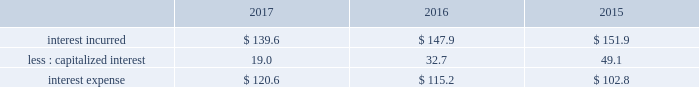Gain on previously held equity interest on 30 december 2014 , we acquired our partner 2019s equity ownership interest in a liquefied atmospheric industrial gases production joint venture in north america for $ 22.6 , which increased our ownership from 50% ( 50 % ) to 100% ( 100 % ) .
The transaction was accounted for as a business combination , and subsequent to the acquisition , the results were consolidated within our industrial gases 2013 americas segment .
We recorded a gain of $ 17.9 ( $ 11.2 after-tax , or $ .05 per share ) as a result of revaluing our previously held equity interest to fair value as of the acquisition date .
Refer to note 6 , business combination , to the consolidated financial statements for additional details .
Other income ( expense ) , net items recorded to other income ( expense ) , net arise from transactions and events not directly related to our principal income earning activities .
The detail of other income ( expense ) , net is presented in note 23 , supplemental information , to the consolidated financial statements .
2017 vs .
2016 other income ( expense ) , net of $ 121.0 increased $ 71.6 , primarily due to income from transition services agreements with versum and evonik , income from the sale of assets and investments , including a gain of $ 12.2 ( $ 7.6 after-tax , or $ .03 per share ) resulting from the sale of a parcel of land , and a favorable foreign exchange impact .
2016 vs .
2015 other income ( expense ) , net of $ 49.4 increased $ 3.9 , primarily due to lower foreign exchange losses , favorable contract settlements , and receipt of a government subsidy .
Fiscal year 2015 included a gain of $ 33.6 ( $ 28.3 after tax , or $ .13 per share ) resulting from the sale of two parcels of land .
No other individual items were significant in comparison to fiscal year 2015 .
Interest expense .
2017 vs .
2016 interest incurred decreased $ 8.3 as the impact from a lower average debt balance of $ 26 was partially offset by the impact from a higher average interest rate on the debt portfolio of $ 19 .
The change in capitalized interest was driven by a decrease in the carrying value of projects under construction , primarily as a result of our decision to exit from the energy-from-waste business .
2016 vs .
2015 interest incurred decreased $ 4.0 .
The decrease primarily resulted from a stronger u.s .
Dollar on the translation of foreign currency interest of $ 6 , partially offset by a higher average debt balance of $ 2 .
The change in capitalized interest was driven by a decrease in the carrying value of projects under construction , primarily as a result of our exit from the energy-from-waste business .
Other non-operating income ( expense ) , net other non-operating income ( expense ) , net of $ 29.0 in fiscal year 2017 primarily resulted from interest income on cash and time deposits , which are comprised primarily of proceeds from the sale of pmd .
Interest income was included in "other income ( expense ) , net" in 2016 and 2015 .
Interest income in previous periods was not material .
Loss on extinguishment of debt on 30 september 2016 , in anticipation of the spin-off of emd , versum issued $ 425.0 of notes to air products , who then exchanged these notes with certain financial institutions for $ 418.3 of air products 2019 outstanding commercial paper .
This noncash exchange , which was excluded from the consolidated statements of cash flows , resulted in a loss of $ 6.9 ( $ 4.3 after-tax , or $ .02 per share ) .
In september 2015 , we made a payment of $ 146.6 to redeem 3000000 unidades de fomento ( 201cuf 201d ) series e 6.30% ( 6.30 % ) bonds due 22 january 2030 that had a carrying value of $ 130.0 and resulted in a net loss of $ 16.6 ( $ 14.2 after-tax , or $ .07 per share ) . .
Considering the years 2015-2017 , what is the average interest expense? 
Rationale: it is the sum of all interest expenses divided by three ( the sum of the years ) .
Computations: table_average(interest expense, none)
Answer: 112.86667. 